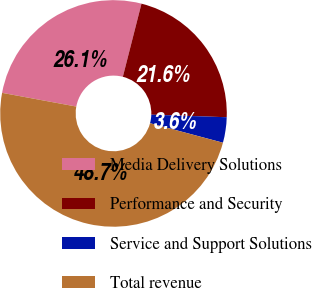Convert chart. <chart><loc_0><loc_0><loc_500><loc_500><pie_chart><fcel>Media Delivery Solutions<fcel>Performance and Security<fcel>Service and Support Solutions<fcel>Total revenue<nl><fcel>26.07%<fcel>21.56%<fcel>3.63%<fcel>48.75%<nl></chart> 